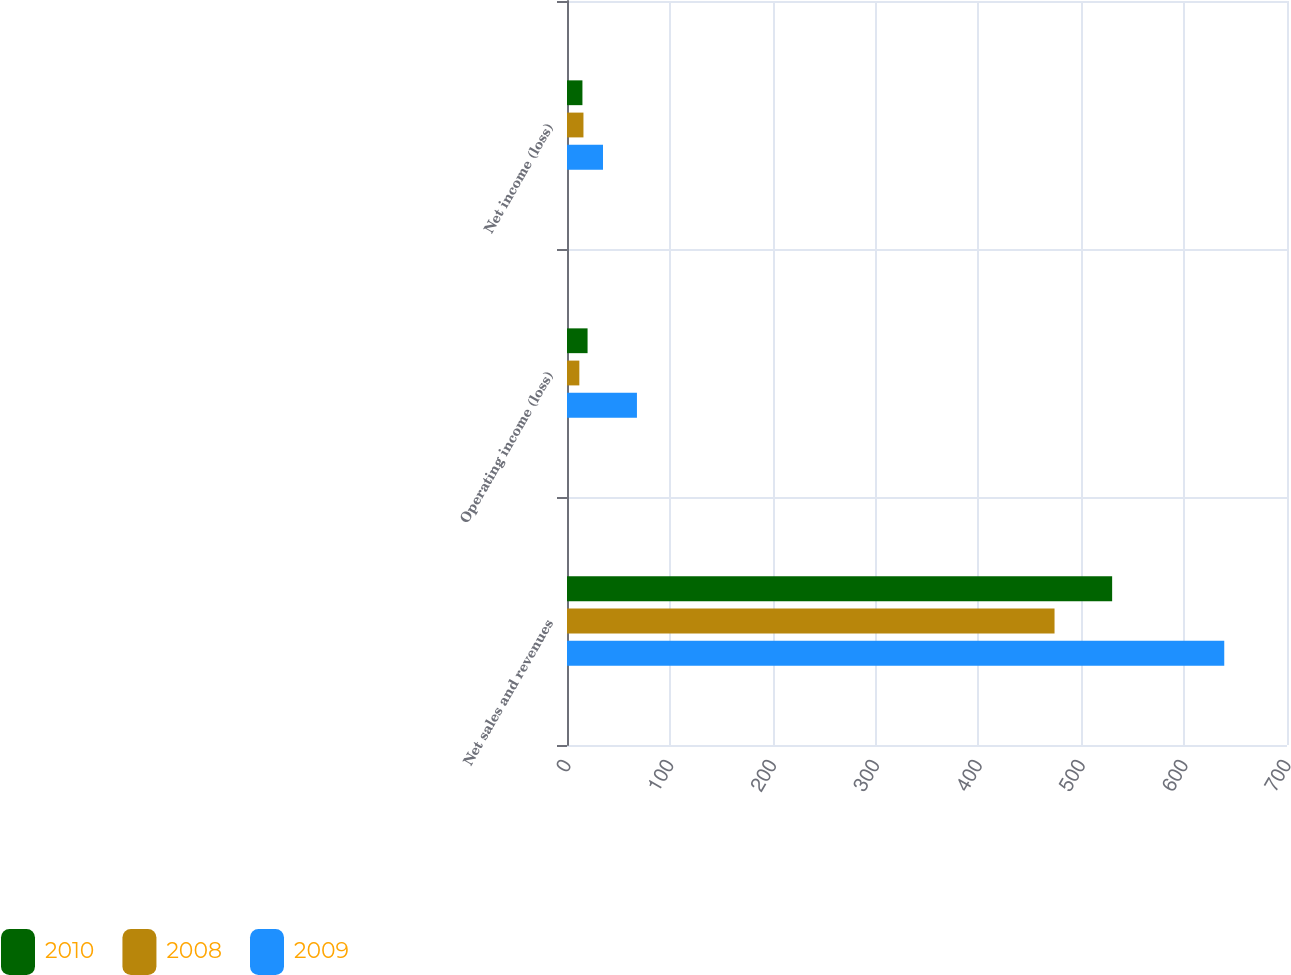Convert chart to OTSL. <chart><loc_0><loc_0><loc_500><loc_500><stacked_bar_chart><ecel><fcel>Net sales and revenues<fcel>Operating income (loss)<fcel>Net income (loss)<nl><fcel>2010<fcel>530<fcel>20<fcel>15<nl><fcel>2008<fcel>474<fcel>12<fcel>16<nl><fcel>2009<fcel>639<fcel>68<fcel>35<nl></chart> 